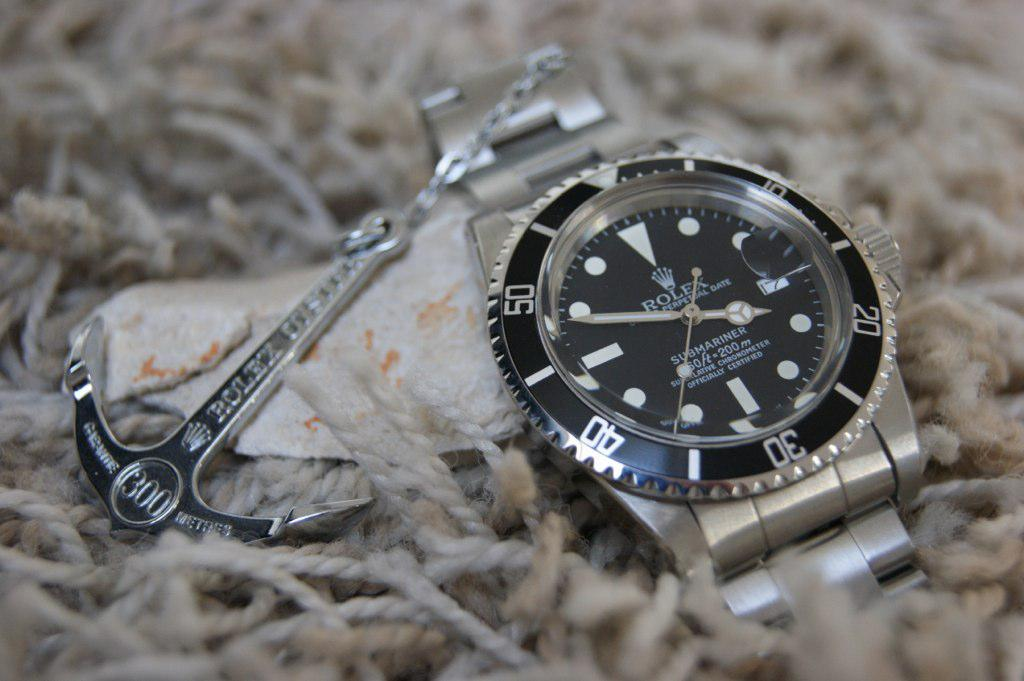<image>
Provide a brief description of the given image. A Rolex watch next to a Rolex mini anchor. 